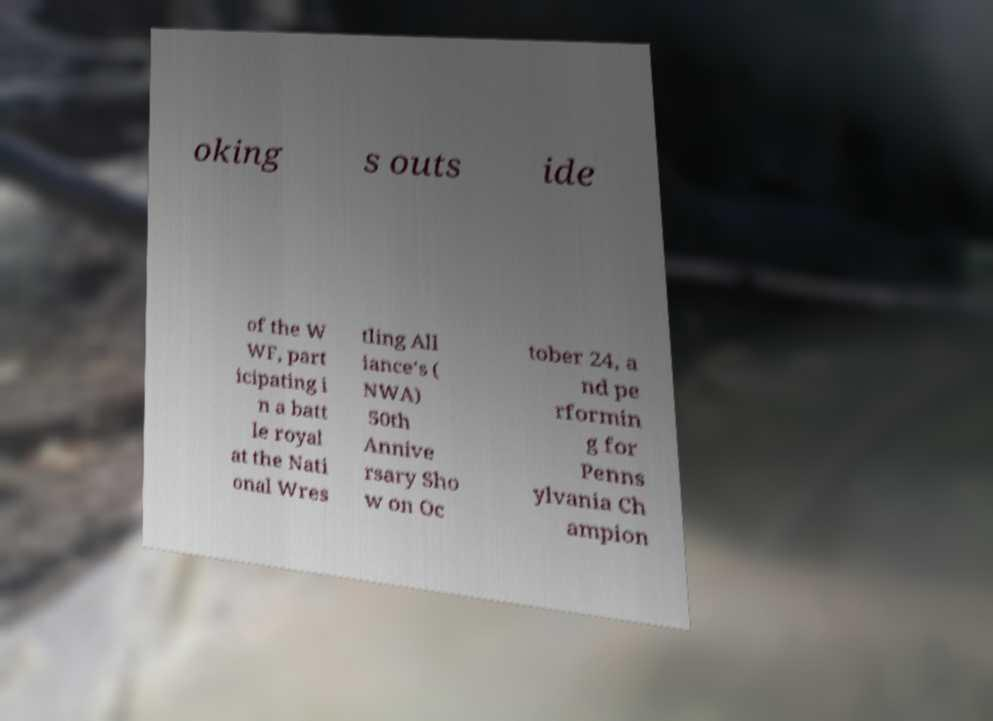Please identify and transcribe the text found in this image. oking s outs ide of the W WF, part icipating i n a batt le royal at the Nati onal Wres tling All iance's ( NWA) 50th Annive rsary Sho w on Oc tober 24, a nd pe rformin g for Penns ylvania Ch ampion 